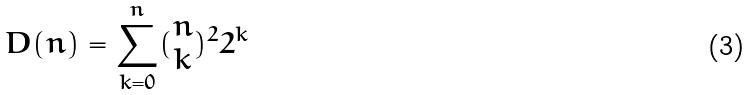Convert formula to latex. <formula><loc_0><loc_0><loc_500><loc_500>D ( n ) = \sum _ { k = 0 } ^ { n } ( \begin{matrix} n \\ k \end{matrix} ) ^ { 2 } 2 ^ { k }</formula> 